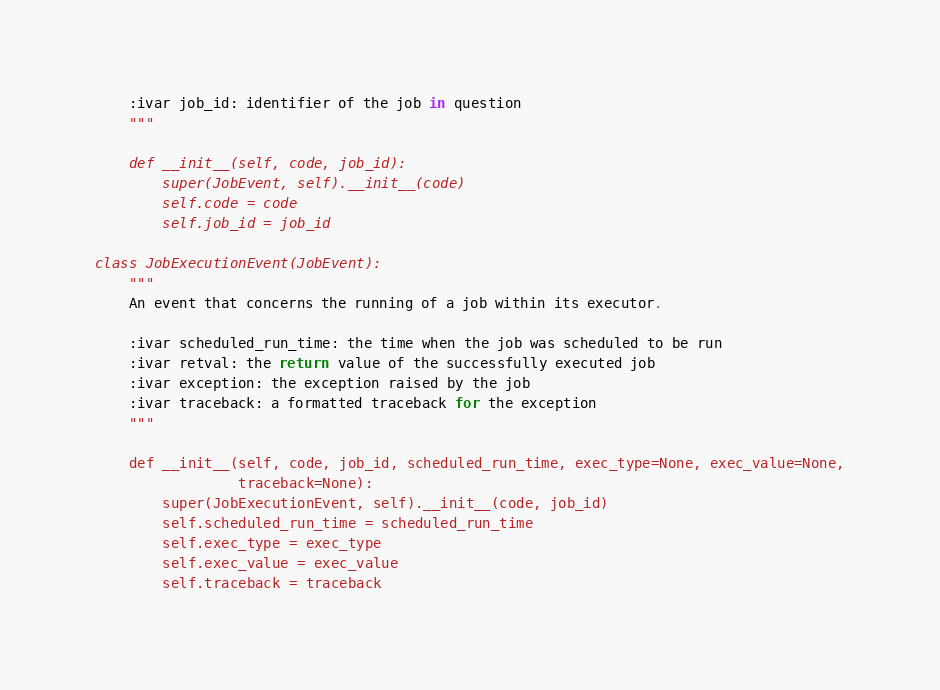Convert code to text. <code><loc_0><loc_0><loc_500><loc_500><_Python_>    :ivar job_id: identifier of the job in question
    """

    def __init__(self, code, job_id):
        super(JobEvent, self).__init__(code)
        self.code = code
        self.job_id = job_id

class JobExecutionEvent(JobEvent):
    """
    An event that concerns the running of a job within its executor.

    :ivar scheduled_run_time: the time when the job was scheduled to be run
    :ivar retval: the return value of the successfully executed job
    :ivar exception: the exception raised by the job
    :ivar traceback: a formatted traceback for the exception
    """

    def __init__(self, code, job_id, scheduled_run_time, exec_type=None, exec_value=None,
                 traceback=None):
        super(JobExecutionEvent, self).__init__(code, job_id)
        self.scheduled_run_time = scheduled_run_time
        self.exec_type = exec_type
        self.exec_value = exec_value
        self.traceback = traceback
</code> 